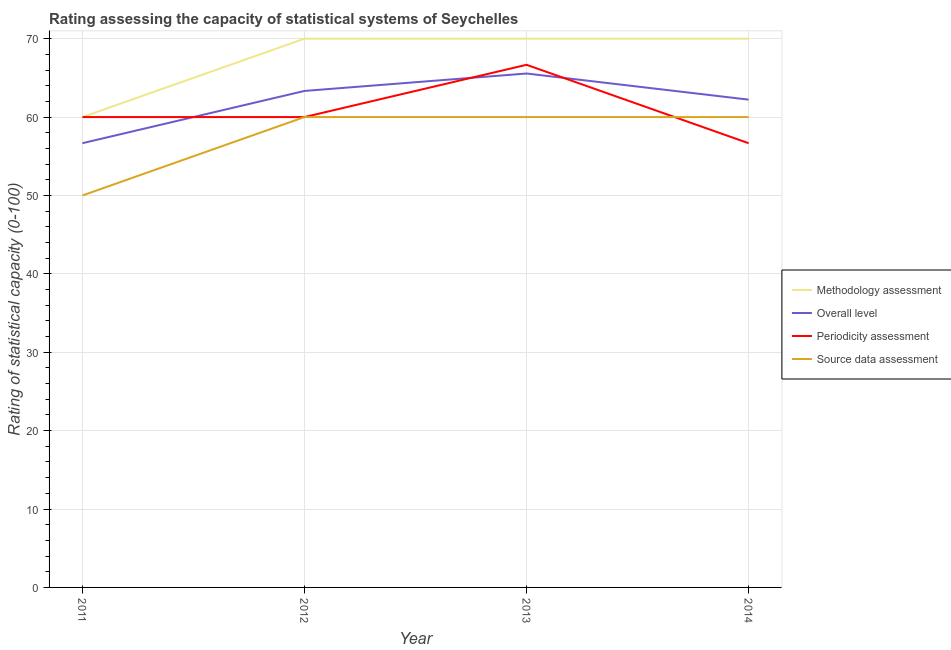How many different coloured lines are there?
Give a very brief answer. 4. Is the number of lines equal to the number of legend labels?
Your answer should be compact. Yes. What is the overall level rating in 2012?
Keep it short and to the point. 63.33. Across all years, what is the maximum periodicity assessment rating?
Offer a terse response. 66.67. Across all years, what is the minimum overall level rating?
Ensure brevity in your answer.  56.67. What is the total overall level rating in the graph?
Keep it short and to the point. 247.78. What is the difference between the periodicity assessment rating in 2013 and that in 2014?
Make the answer very short. 10. What is the difference between the methodology assessment rating in 2011 and the overall level rating in 2012?
Give a very brief answer. -3.33. What is the average methodology assessment rating per year?
Provide a succinct answer. 67.5. In the year 2011, what is the difference between the periodicity assessment rating and source data assessment rating?
Offer a very short reply. 10. What is the ratio of the periodicity assessment rating in 2011 to that in 2014?
Your answer should be compact. 1.06. Is the difference between the source data assessment rating in 2012 and 2014 greater than the difference between the methodology assessment rating in 2012 and 2014?
Give a very brief answer. No. What is the difference between the highest and the second highest overall level rating?
Offer a very short reply. 2.22. What is the difference between the highest and the lowest overall level rating?
Provide a short and direct response. 8.89. Is the sum of the overall level rating in 2013 and 2014 greater than the maximum methodology assessment rating across all years?
Your response must be concise. Yes. Is the source data assessment rating strictly greater than the periodicity assessment rating over the years?
Provide a short and direct response. No. How many lines are there?
Give a very brief answer. 4. How many years are there in the graph?
Provide a short and direct response. 4. What is the difference between two consecutive major ticks on the Y-axis?
Make the answer very short. 10. What is the title of the graph?
Your response must be concise. Rating assessing the capacity of statistical systems of Seychelles. What is the label or title of the X-axis?
Keep it short and to the point. Year. What is the label or title of the Y-axis?
Provide a succinct answer. Rating of statistical capacity (0-100). What is the Rating of statistical capacity (0-100) of Overall level in 2011?
Keep it short and to the point. 56.67. What is the Rating of statistical capacity (0-100) in Overall level in 2012?
Your answer should be compact. 63.33. What is the Rating of statistical capacity (0-100) of Periodicity assessment in 2012?
Your answer should be very brief. 60. What is the Rating of statistical capacity (0-100) in Source data assessment in 2012?
Provide a short and direct response. 60. What is the Rating of statistical capacity (0-100) of Overall level in 2013?
Provide a succinct answer. 65.56. What is the Rating of statistical capacity (0-100) in Periodicity assessment in 2013?
Offer a terse response. 66.67. What is the Rating of statistical capacity (0-100) in Source data assessment in 2013?
Keep it short and to the point. 60. What is the Rating of statistical capacity (0-100) in Overall level in 2014?
Your response must be concise. 62.22. What is the Rating of statistical capacity (0-100) of Periodicity assessment in 2014?
Provide a short and direct response. 56.67. Across all years, what is the maximum Rating of statistical capacity (0-100) in Methodology assessment?
Offer a terse response. 70. Across all years, what is the maximum Rating of statistical capacity (0-100) in Overall level?
Offer a very short reply. 65.56. Across all years, what is the maximum Rating of statistical capacity (0-100) in Periodicity assessment?
Offer a terse response. 66.67. Across all years, what is the minimum Rating of statistical capacity (0-100) of Overall level?
Ensure brevity in your answer.  56.67. Across all years, what is the minimum Rating of statistical capacity (0-100) in Periodicity assessment?
Your answer should be compact. 56.67. What is the total Rating of statistical capacity (0-100) in Methodology assessment in the graph?
Keep it short and to the point. 270. What is the total Rating of statistical capacity (0-100) of Overall level in the graph?
Give a very brief answer. 247.78. What is the total Rating of statistical capacity (0-100) of Periodicity assessment in the graph?
Ensure brevity in your answer.  243.33. What is the total Rating of statistical capacity (0-100) of Source data assessment in the graph?
Your response must be concise. 230. What is the difference between the Rating of statistical capacity (0-100) of Methodology assessment in 2011 and that in 2012?
Provide a short and direct response. -10. What is the difference between the Rating of statistical capacity (0-100) of Overall level in 2011 and that in 2012?
Provide a succinct answer. -6.67. What is the difference between the Rating of statistical capacity (0-100) of Periodicity assessment in 2011 and that in 2012?
Provide a succinct answer. 0. What is the difference between the Rating of statistical capacity (0-100) of Source data assessment in 2011 and that in 2012?
Provide a succinct answer. -10. What is the difference between the Rating of statistical capacity (0-100) in Overall level in 2011 and that in 2013?
Offer a terse response. -8.89. What is the difference between the Rating of statistical capacity (0-100) in Periodicity assessment in 2011 and that in 2013?
Keep it short and to the point. -6.67. What is the difference between the Rating of statistical capacity (0-100) in Source data assessment in 2011 and that in 2013?
Ensure brevity in your answer.  -10. What is the difference between the Rating of statistical capacity (0-100) of Methodology assessment in 2011 and that in 2014?
Provide a short and direct response. -10. What is the difference between the Rating of statistical capacity (0-100) of Overall level in 2011 and that in 2014?
Your response must be concise. -5.56. What is the difference between the Rating of statistical capacity (0-100) in Periodicity assessment in 2011 and that in 2014?
Your response must be concise. 3.33. What is the difference between the Rating of statistical capacity (0-100) in Source data assessment in 2011 and that in 2014?
Provide a short and direct response. -10. What is the difference between the Rating of statistical capacity (0-100) of Overall level in 2012 and that in 2013?
Your answer should be very brief. -2.22. What is the difference between the Rating of statistical capacity (0-100) of Periodicity assessment in 2012 and that in 2013?
Your response must be concise. -6.67. What is the difference between the Rating of statistical capacity (0-100) in Source data assessment in 2012 and that in 2013?
Keep it short and to the point. 0. What is the difference between the Rating of statistical capacity (0-100) of Methodology assessment in 2012 and that in 2014?
Offer a very short reply. 0. What is the difference between the Rating of statistical capacity (0-100) in Methodology assessment in 2013 and that in 2014?
Offer a terse response. 0. What is the difference between the Rating of statistical capacity (0-100) of Overall level in 2013 and that in 2014?
Provide a succinct answer. 3.33. What is the difference between the Rating of statistical capacity (0-100) of Periodicity assessment in 2013 and that in 2014?
Provide a short and direct response. 10. What is the difference between the Rating of statistical capacity (0-100) of Source data assessment in 2013 and that in 2014?
Provide a short and direct response. 0. What is the difference between the Rating of statistical capacity (0-100) in Methodology assessment in 2011 and the Rating of statistical capacity (0-100) in Overall level in 2012?
Make the answer very short. -3.33. What is the difference between the Rating of statistical capacity (0-100) in Methodology assessment in 2011 and the Rating of statistical capacity (0-100) in Periodicity assessment in 2012?
Offer a terse response. 0. What is the difference between the Rating of statistical capacity (0-100) in Overall level in 2011 and the Rating of statistical capacity (0-100) in Periodicity assessment in 2012?
Give a very brief answer. -3.33. What is the difference between the Rating of statistical capacity (0-100) of Periodicity assessment in 2011 and the Rating of statistical capacity (0-100) of Source data assessment in 2012?
Your answer should be very brief. 0. What is the difference between the Rating of statistical capacity (0-100) of Methodology assessment in 2011 and the Rating of statistical capacity (0-100) of Overall level in 2013?
Make the answer very short. -5.56. What is the difference between the Rating of statistical capacity (0-100) in Methodology assessment in 2011 and the Rating of statistical capacity (0-100) in Periodicity assessment in 2013?
Provide a succinct answer. -6.67. What is the difference between the Rating of statistical capacity (0-100) of Methodology assessment in 2011 and the Rating of statistical capacity (0-100) of Source data assessment in 2013?
Give a very brief answer. 0. What is the difference between the Rating of statistical capacity (0-100) of Methodology assessment in 2011 and the Rating of statistical capacity (0-100) of Overall level in 2014?
Your response must be concise. -2.22. What is the difference between the Rating of statistical capacity (0-100) in Methodology assessment in 2011 and the Rating of statistical capacity (0-100) in Periodicity assessment in 2014?
Your answer should be very brief. 3.33. What is the difference between the Rating of statistical capacity (0-100) in Methodology assessment in 2011 and the Rating of statistical capacity (0-100) in Source data assessment in 2014?
Offer a terse response. 0. What is the difference between the Rating of statistical capacity (0-100) in Overall level in 2011 and the Rating of statistical capacity (0-100) in Periodicity assessment in 2014?
Provide a succinct answer. 0. What is the difference between the Rating of statistical capacity (0-100) in Periodicity assessment in 2011 and the Rating of statistical capacity (0-100) in Source data assessment in 2014?
Provide a short and direct response. 0. What is the difference between the Rating of statistical capacity (0-100) in Methodology assessment in 2012 and the Rating of statistical capacity (0-100) in Overall level in 2013?
Keep it short and to the point. 4.44. What is the difference between the Rating of statistical capacity (0-100) of Methodology assessment in 2012 and the Rating of statistical capacity (0-100) of Overall level in 2014?
Ensure brevity in your answer.  7.78. What is the difference between the Rating of statistical capacity (0-100) in Methodology assessment in 2012 and the Rating of statistical capacity (0-100) in Periodicity assessment in 2014?
Your answer should be compact. 13.33. What is the difference between the Rating of statistical capacity (0-100) in Overall level in 2012 and the Rating of statistical capacity (0-100) in Periodicity assessment in 2014?
Keep it short and to the point. 6.67. What is the difference between the Rating of statistical capacity (0-100) in Overall level in 2012 and the Rating of statistical capacity (0-100) in Source data assessment in 2014?
Your response must be concise. 3.33. What is the difference between the Rating of statistical capacity (0-100) of Periodicity assessment in 2012 and the Rating of statistical capacity (0-100) of Source data assessment in 2014?
Offer a very short reply. 0. What is the difference between the Rating of statistical capacity (0-100) in Methodology assessment in 2013 and the Rating of statistical capacity (0-100) in Overall level in 2014?
Keep it short and to the point. 7.78. What is the difference between the Rating of statistical capacity (0-100) in Methodology assessment in 2013 and the Rating of statistical capacity (0-100) in Periodicity assessment in 2014?
Offer a very short reply. 13.33. What is the difference between the Rating of statistical capacity (0-100) in Methodology assessment in 2013 and the Rating of statistical capacity (0-100) in Source data assessment in 2014?
Your answer should be very brief. 10. What is the difference between the Rating of statistical capacity (0-100) of Overall level in 2013 and the Rating of statistical capacity (0-100) of Periodicity assessment in 2014?
Provide a succinct answer. 8.89. What is the difference between the Rating of statistical capacity (0-100) of Overall level in 2013 and the Rating of statistical capacity (0-100) of Source data assessment in 2014?
Your answer should be compact. 5.56. What is the average Rating of statistical capacity (0-100) of Methodology assessment per year?
Provide a succinct answer. 67.5. What is the average Rating of statistical capacity (0-100) of Overall level per year?
Make the answer very short. 61.94. What is the average Rating of statistical capacity (0-100) in Periodicity assessment per year?
Make the answer very short. 60.83. What is the average Rating of statistical capacity (0-100) of Source data assessment per year?
Offer a terse response. 57.5. In the year 2011, what is the difference between the Rating of statistical capacity (0-100) in Methodology assessment and Rating of statistical capacity (0-100) in Overall level?
Offer a very short reply. 3.33. In the year 2011, what is the difference between the Rating of statistical capacity (0-100) of Methodology assessment and Rating of statistical capacity (0-100) of Periodicity assessment?
Give a very brief answer. 0. In the year 2011, what is the difference between the Rating of statistical capacity (0-100) of Methodology assessment and Rating of statistical capacity (0-100) of Source data assessment?
Offer a terse response. 10. In the year 2011, what is the difference between the Rating of statistical capacity (0-100) of Overall level and Rating of statistical capacity (0-100) of Periodicity assessment?
Offer a very short reply. -3.33. In the year 2012, what is the difference between the Rating of statistical capacity (0-100) in Methodology assessment and Rating of statistical capacity (0-100) in Overall level?
Your answer should be very brief. 6.67. In the year 2012, what is the difference between the Rating of statistical capacity (0-100) in Methodology assessment and Rating of statistical capacity (0-100) in Periodicity assessment?
Your response must be concise. 10. In the year 2012, what is the difference between the Rating of statistical capacity (0-100) in Overall level and Rating of statistical capacity (0-100) in Source data assessment?
Provide a succinct answer. 3.33. In the year 2012, what is the difference between the Rating of statistical capacity (0-100) of Periodicity assessment and Rating of statistical capacity (0-100) of Source data assessment?
Offer a very short reply. 0. In the year 2013, what is the difference between the Rating of statistical capacity (0-100) of Methodology assessment and Rating of statistical capacity (0-100) of Overall level?
Ensure brevity in your answer.  4.44. In the year 2013, what is the difference between the Rating of statistical capacity (0-100) in Methodology assessment and Rating of statistical capacity (0-100) in Source data assessment?
Give a very brief answer. 10. In the year 2013, what is the difference between the Rating of statistical capacity (0-100) of Overall level and Rating of statistical capacity (0-100) of Periodicity assessment?
Provide a short and direct response. -1.11. In the year 2013, what is the difference between the Rating of statistical capacity (0-100) in Overall level and Rating of statistical capacity (0-100) in Source data assessment?
Provide a short and direct response. 5.56. In the year 2013, what is the difference between the Rating of statistical capacity (0-100) of Periodicity assessment and Rating of statistical capacity (0-100) of Source data assessment?
Your answer should be very brief. 6.67. In the year 2014, what is the difference between the Rating of statistical capacity (0-100) in Methodology assessment and Rating of statistical capacity (0-100) in Overall level?
Give a very brief answer. 7.78. In the year 2014, what is the difference between the Rating of statistical capacity (0-100) in Methodology assessment and Rating of statistical capacity (0-100) in Periodicity assessment?
Make the answer very short. 13.33. In the year 2014, what is the difference between the Rating of statistical capacity (0-100) of Methodology assessment and Rating of statistical capacity (0-100) of Source data assessment?
Your response must be concise. 10. In the year 2014, what is the difference between the Rating of statistical capacity (0-100) in Overall level and Rating of statistical capacity (0-100) in Periodicity assessment?
Make the answer very short. 5.56. In the year 2014, what is the difference between the Rating of statistical capacity (0-100) of Overall level and Rating of statistical capacity (0-100) of Source data assessment?
Your response must be concise. 2.22. In the year 2014, what is the difference between the Rating of statistical capacity (0-100) of Periodicity assessment and Rating of statistical capacity (0-100) of Source data assessment?
Provide a succinct answer. -3.33. What is the ratio of the Rating of statistical capacity (0-100) of Overall level in 2011 to that in 2012?
Give a very brief answer. 0.89. What is the ratio of the Rating of statistical capacity (0-100) in Periodicity assessment in 2011 to that in 2012?
Your response must be concise. 1. What is the ratio of the Rating of statistical capacity (0-100) in Source data assessment in 2011 to that in 2012?
Your answer should be compact. 0.83. What is the ratio of the Rating of statistical capacity (0-100) in Methodology assessment in 2011 to that in 2013?
Provide a short and direct response. 0.86. What is the ratio of the Rating of statistical capacity (0-100) in Overall level in 2011 to that in 2013?
Your answer should be very brief. 0.86. What is the ratio of the Rating of statistical capacity (0-100) in Overall level in 2011 to that in 2014?
Provide a succinct answer. 0.91. What is the ratio of the Rating of statistical capacity (0-100) in Periodicity assessment in 2011 to that in 2014?
Provide a short and direct response. 1.06. What is the ratio of the Rating of statistical capacity (0-100) in Overall level in 2012 to that in 2013?
Offer a terse response. 0.97. What is the ratio of the Rating of statistical capacity (0-100) of Source data assessment in 2012 to that in 2013?
Your answer should be compact. 1. What is the ratio of the Rating of statistical capacity (0-100) of Methodology assessment in 2012 to that in 2014?
Provide a succinct answer. 1. What is the ratio of the Rating of statistical capacity (0-100) of Overall level in 2012 to that in 2014?
Offer a very short reply. 1.02. What is the ratio of the Rating of statistical capacity (0-100) in Periodicity assessment in 2012 to that in 2014?
Offer a very short reply. 1.06. What is the ratio of the Rating of statistical capacity (0-100) of Source data assessment in 2012 to that in 2014?
Offer a very short reply. 1. What is the ratio of the Rating of statistical capacity (0-100) in Overall level in 2013 to that in 2014?
Provide a succinct answer. 1.05. What is the ratio of the Rating of statistical capacity (0-100) of Periodicity assessment in 2013 to that in 2014?
Give a very brief answer. 1.18. What is the difference between the highest and the second highest Rating of statistical capacity (0-100) in Overall level?
Your response must be concise. 2.22. What is the difference between the highest and the second highest Rating of statistical capacity (0-100) of Periodicity assessment?
Offer a very short reply. 6.67. What is the difference between the highest and the second highest Rating of statistical capacity (0-100) in Source data assessment?
Your answer should be compact. 0. What is the difference between the highest and the lowest Rating of statistical capacity (0-100) of Overall level?
Provide a short and direct response. 8.89. What is the difference between the highest and the lowest Rating of statistical capacity (0-100) in Periodicity assessment?
Your answer should be very brief. 10. 